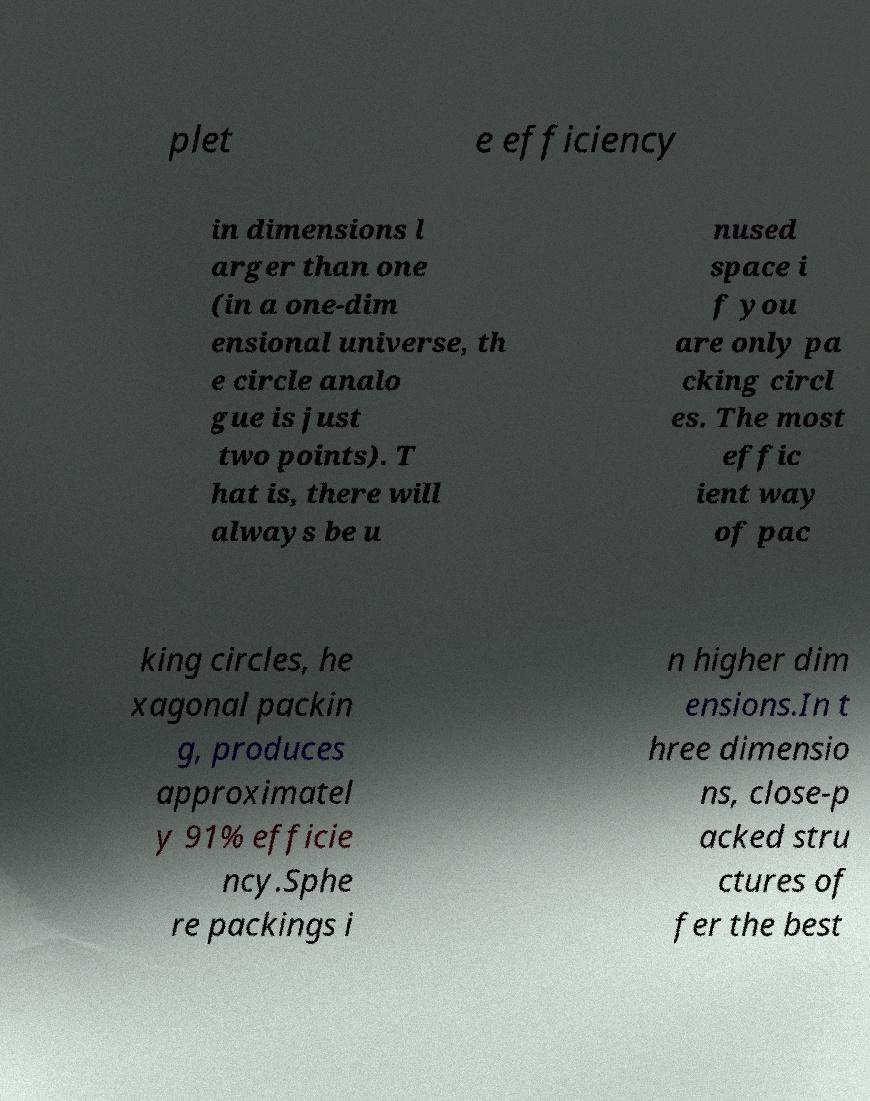Please identify and transcribe the text found in this image. plet e efficiency in dimensions l arger than one (in a one-dim ensional universe, th e circle analo gue is just two points). T hat is, there will always be u nused space i f you are only pa cking circl es. The most effic ient way of pac king circles, he xagonal packin g, produces approximatel y 91% efficie ncy.Sphe re packings i n higher dim ensions.In t hree dimensio ns, close-p acked stru ctures of fer the best 